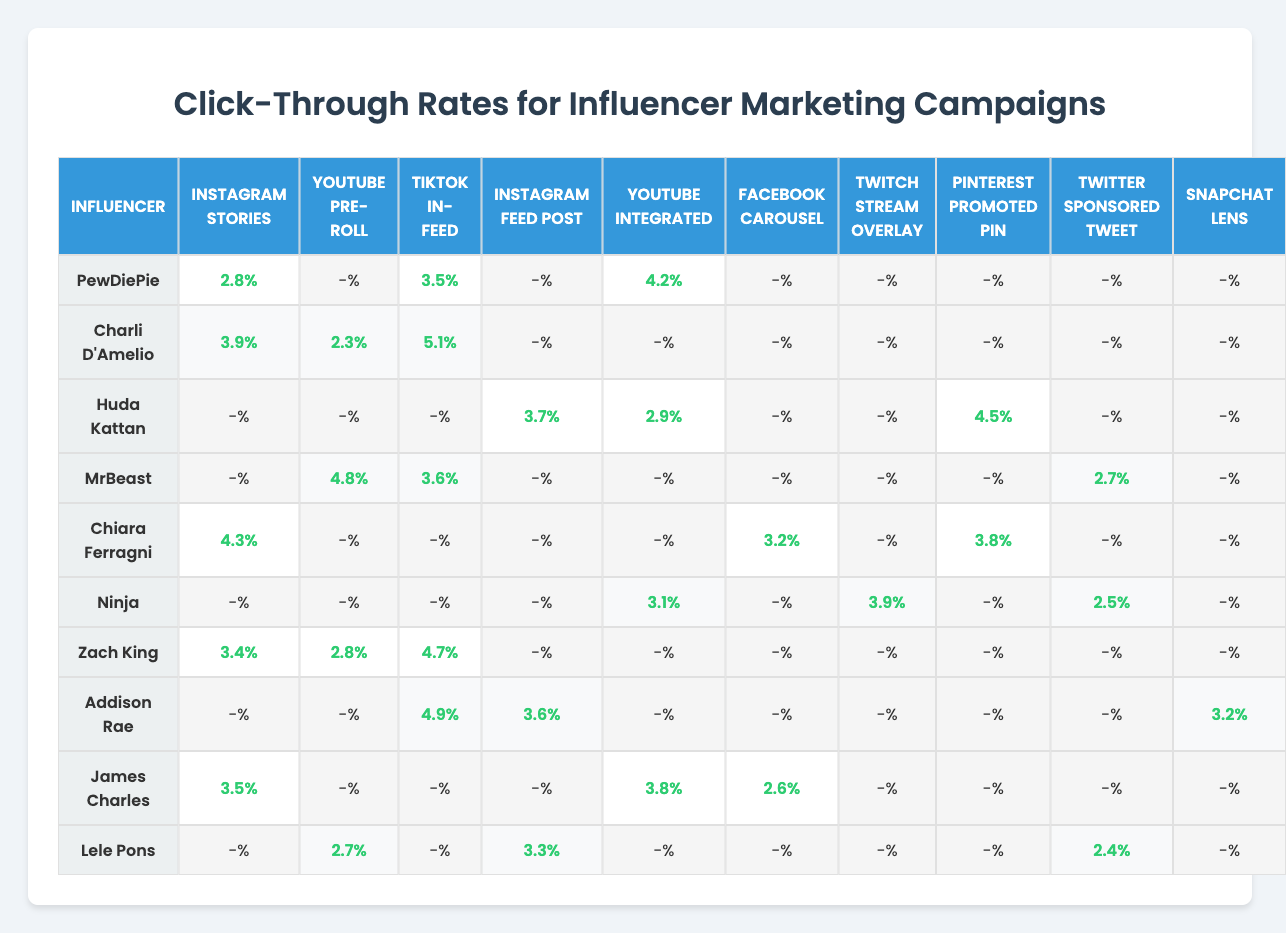What is the click-through rate for TikTok In-Feed by Charli D'Amelio? The table indicates that Charli D'Amelio has a click-through rate of 5.1% for TikTok In-Feed.
Answer: 5.1% Which influencer has the highest click-through rate on Instagram Stories? In the table, Charli D'Amelio has the highest click-through rate at 3.9% for Instagram Stories.
Answer: Charli D'Amelio What is the click-through rate for the YouTube Pre-Roll ad format by MrBeast? According to the table, MrBeast has a click-through rate of 4.8% for the YouTube Pre-Roll ad format.
Answer: 4.8% Which ad format has the lowest click-through rate listed for Ninja? From the table, Ninja has the lowest click-through rate of 2.5% for Twitter Sponsored Tweet.
Answer: Twitter Sponsored Tweet What is the average click-through rate for Zach King across all ad formats present in the table? Zach King's rates are 4.7% (TikTok In-Feed), 3.4% (Instagram Stories), and 2.8% (YouTube Pre-Roll). Summing these gives 4.7 + 3.4 + 2.8 = 11.3. Dividing by the number of formats (3) gives an average of 11.3/3 = 3.77%.
Answer: 3.77% Is there an ad format where Lele Pons has a click-through rate more than 3%? According to the table, Lele Pons only has a click-through rate of 3.3% for Instagram Feed Post, which is the only value above 3%. So, yes, she has a rate above 3%, but not for all formats.
Answer: Yes What is the difference in click-through rates between PewDiePie and Addison Rae for Instagram Stories? PewDiePie has a rate of 2.8% while Addison Rae does not have a rate listed for this format, so it is considered 0%. The difference is 2.8% - 0% = 2.8%.
Answer: 2.8% Which influencer has the highest overall click-through rate in the table? By reviewing the higher click-through rates, Charli D'Amelio's highest rate on TikTok In-Feed is 5.1%, but when considering all influencers, Charli D'Amelio's overall rates are 5.1, 3.9, and 2.3 which total 11.3, dividing by 3 gives 3.77%. The highest single rate is Charli D'Amelio's TikTok In-Feed at 5.1%.
Answer: Charli D'Amelio What percentage of influencers have click-through rates for the Facebook Carousel ad format? Looking at the table, only James Charles and Chiara Ferragni have click-through rates listed, making it 2 out of 10 influencers. Thus, the percentage is (2/10)*100 = 20%.
Answer: 20% Are there any influencers with the same click-through rate for Instagram Stories? Referring to the table, both Zach King (3.4%) and Charli D'Amelio (3.9%) have their respective rates but are different from each other. Therefore, there are no influencers with the same rate for Instagram Stories.
Answer: No 